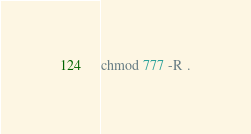Convert code to text. <code><loc_0><loc_0><loc_500><loc_500><_Bash_>chmod 777 -R .</code> 